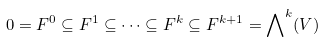<formula> <loc_0><loc_0><loc_500><loc_500>0 = F ^ { 0 } \subseteq F ^ { 1 } \subseteq \cdots \subseteq F ^ { k } \subseteq F ^ { k + 1 } = { \bigwedge } ^ { k } ( V )</formula> 